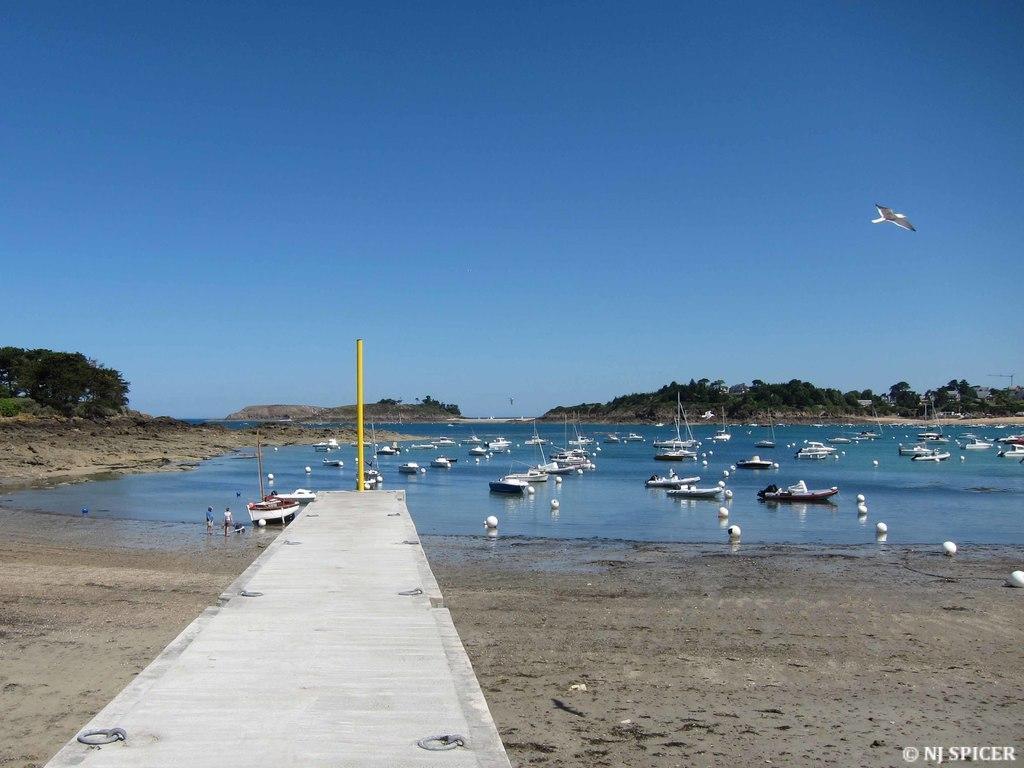Describe this image in one or two sentences. In this image there are boats in a river and there is a path, in the background there are mountains and trees and a blue sky. 